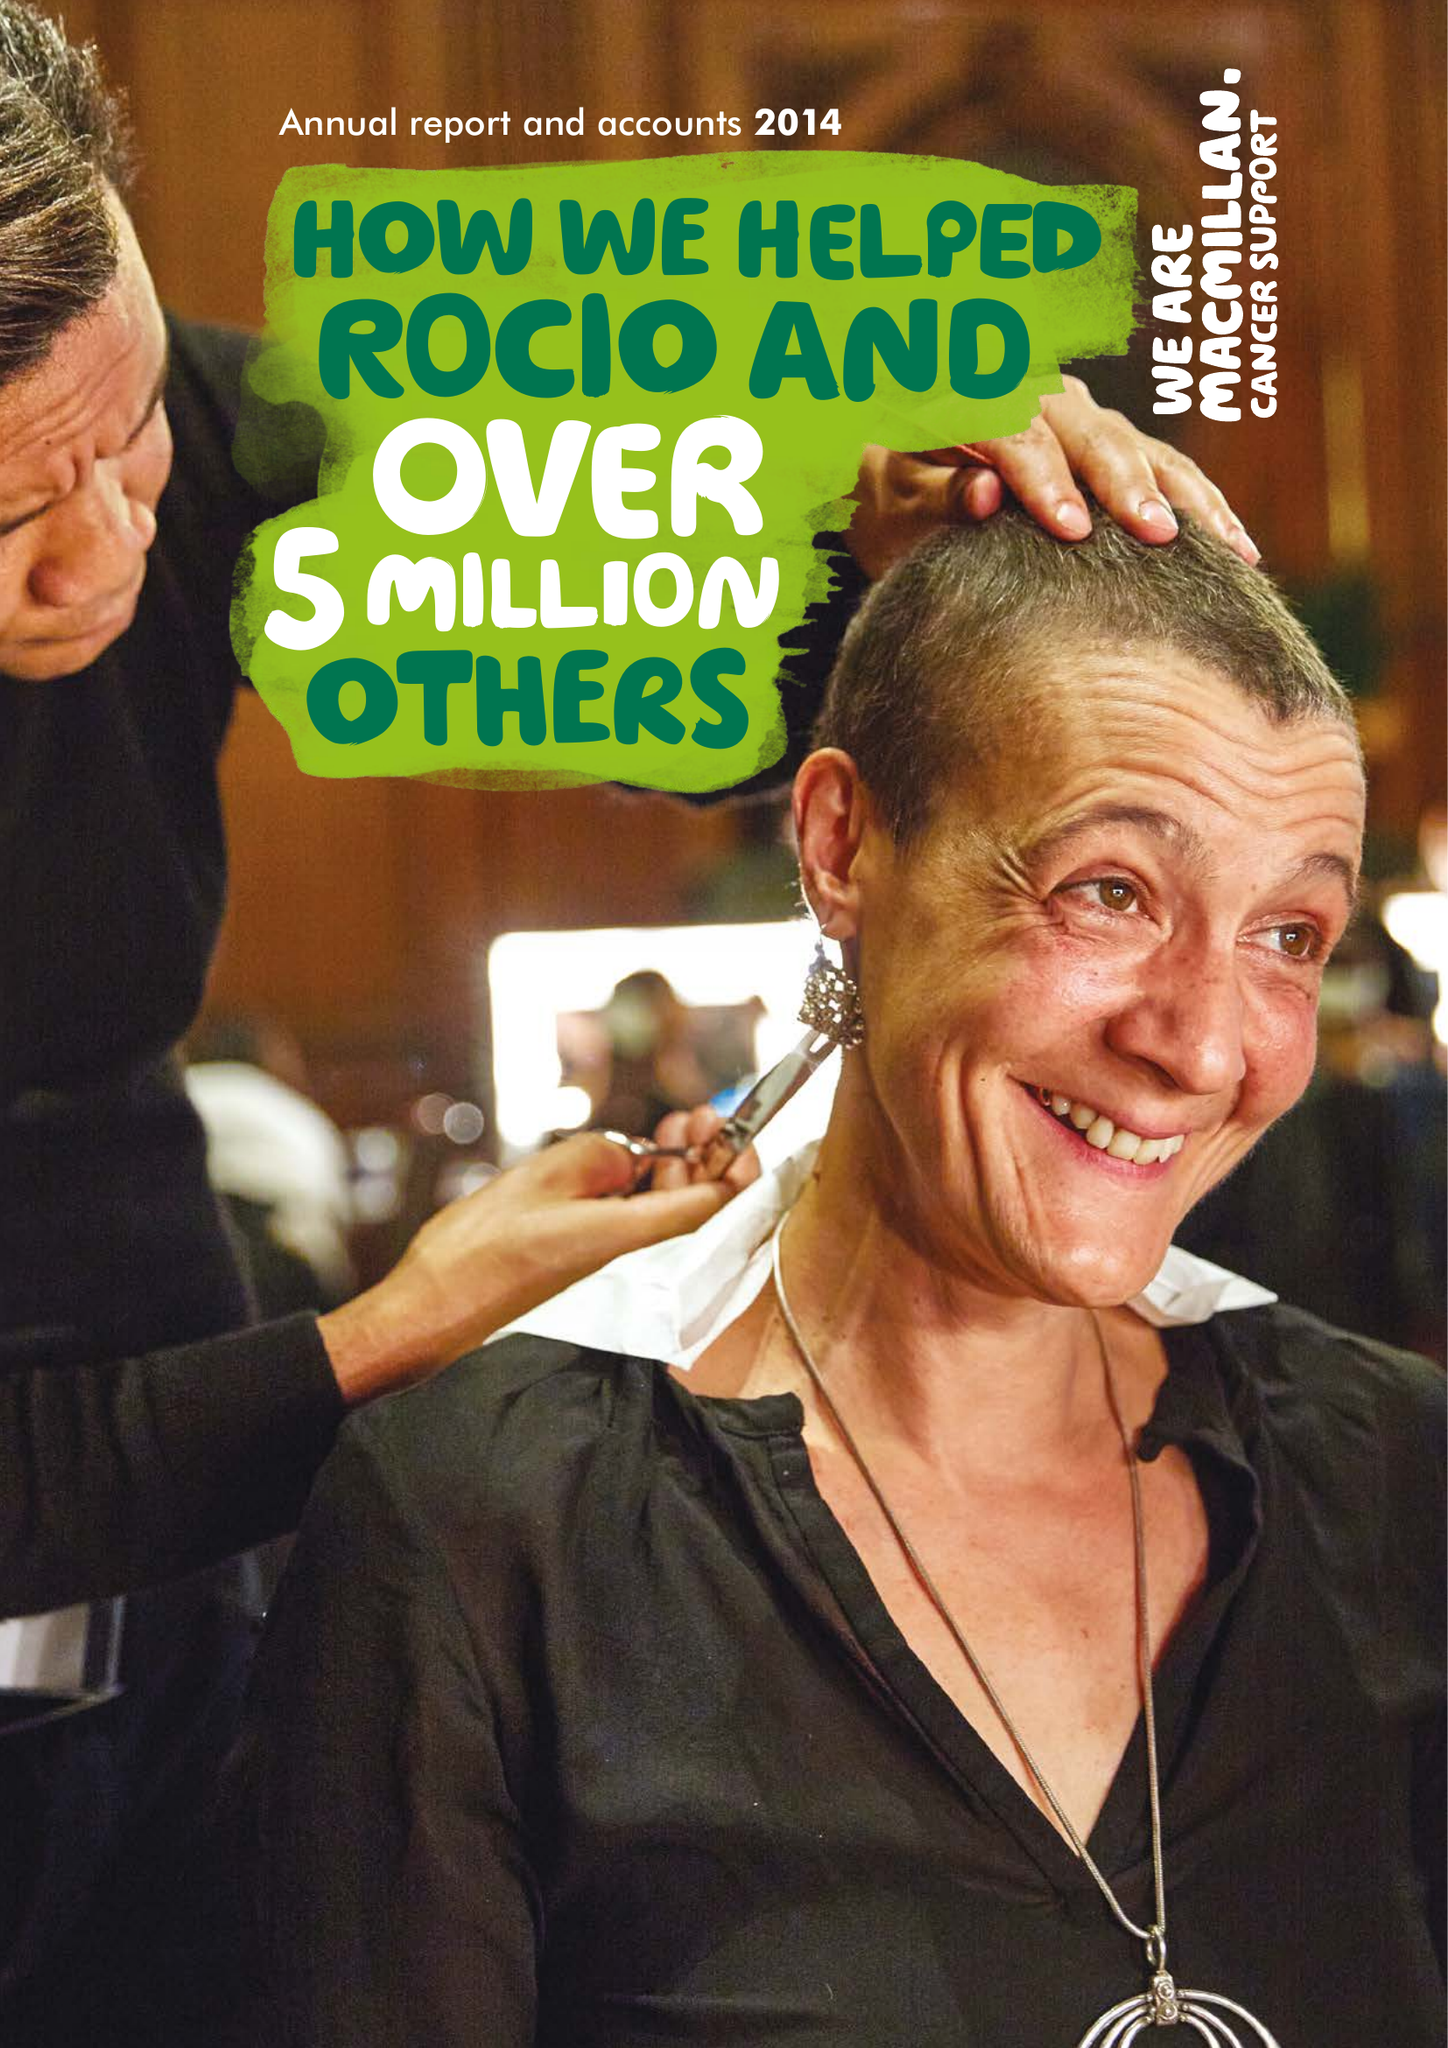What is the value for the spending_annually_in_british_pounds?
Answer the question using a single word or phrase. 221509000.00 